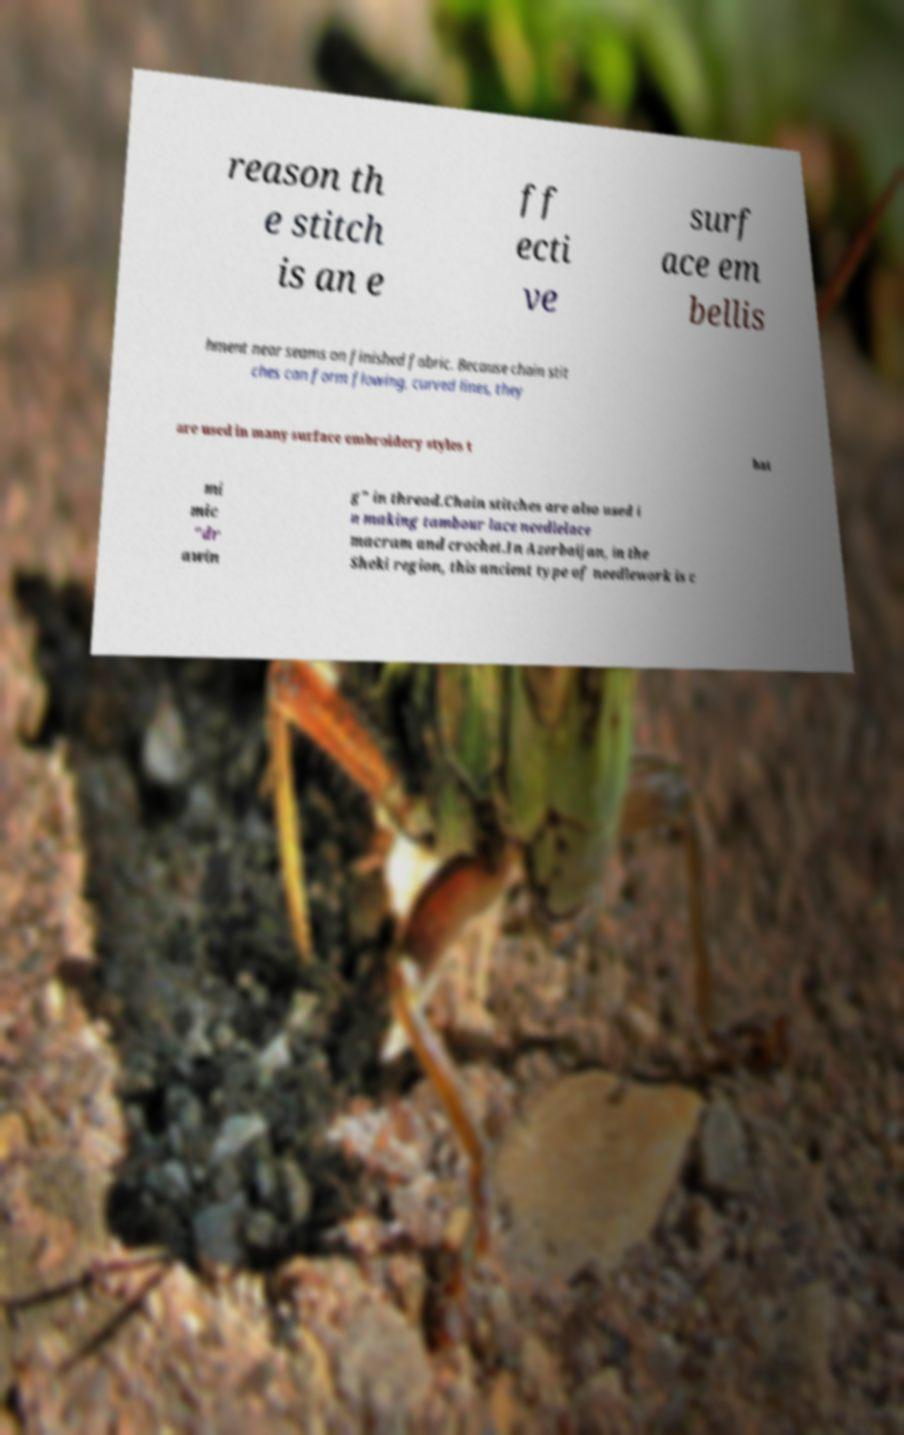Can you accurately transcribe the text from the provided image for me? reason th e stitch is an e ff ecti ve surf ace em bellis hment near seams on finished fabric. Because chain stit ches can form flowing, curved lines, they are used in many surface embroidery styles t hat mi mic "dr awin g" in thread.Chain stitches are also used i n making tambour lace needlelace macram and crochet.In Azerbaijan, in the Sheki region, this ancient type of needlework is c 